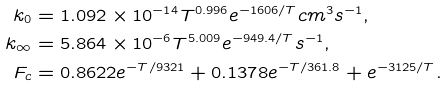Convert formula to latex. <formula><loc_0><loc_0><loc_500><loc_500>k _ { 0 } & = 1 . 0 9 2 \times 1 0 ^ { - 1 4 } T ^ { 0 . 9 9 6 } e ^ { - 1 6 0 6 / T } c m ^ { 3 } s ^ { - 1 } , \\ k _ { \infty } & = 5 . 8 6 4 \times 1 0 ^ { - 6 } T ^ { 5 . 0 0 9 } e ^ { - 9 4 9 . 4 / T } s ^ { - 1 } , \\ F _ { c } & = 0 . 8 6 2 2 e ^ { - T / 9 3 2 1 } + 0 . 1 3 7 8 e ^ { - T / 3 6 1 . 8 } + e ^ { - 3 1 2 5 / T } .</formula> 